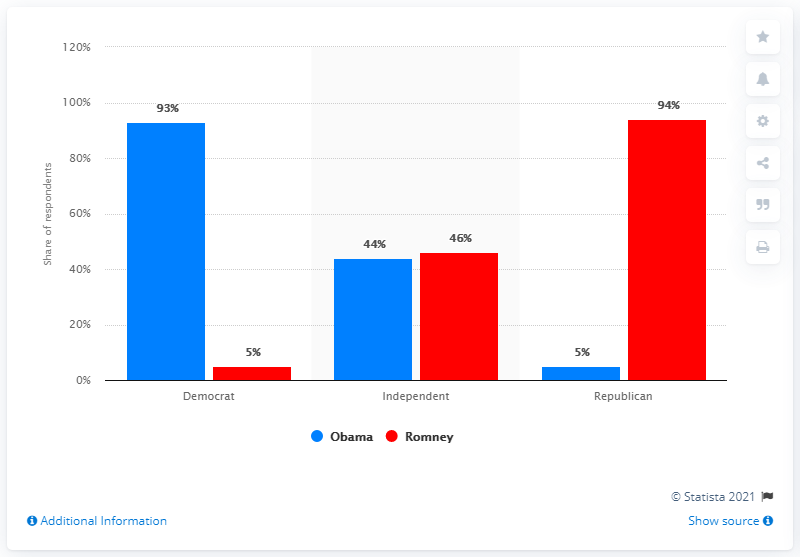Specify some key components in this picture. Red indicates Romney, the leader. The Independent party has the least difference between its two leaders. 